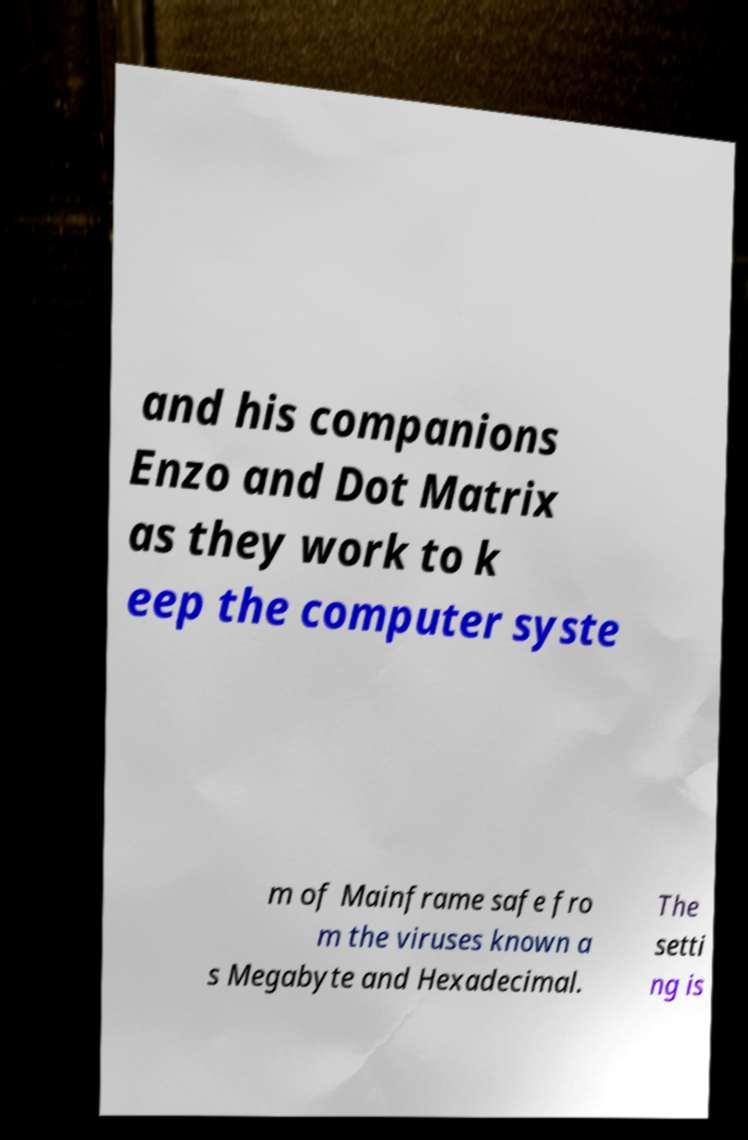Could you extract and type out the text from this image? and his companions Enzo and Dot Matrix as they work to k eep the computer syste m of Mainframe safe fro m the viruses known a s Megabyte and Hexadecimal. The setti ng is 